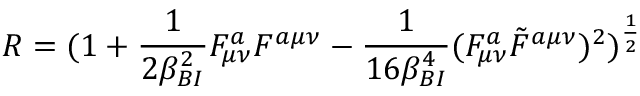<formula> <loc_0><loc_0><loc_500><loc_500>R = ( 1 + { \frac { 1 } { 2 \beta _ { B I } ^ { 2 } } } F _ { \mu \nu } ^ { a } F ^ { a \mu \nu } - { \frac { 1 } { 1 6 \beta _ { B I } ^ { 4 } } } ( F _ { \mu \nu } ^ { a } \tilde { F } ^ { a \mu \nu } ) ^ { 2 } ) ^ { \frac { 1 } { 2 } }</formula> 